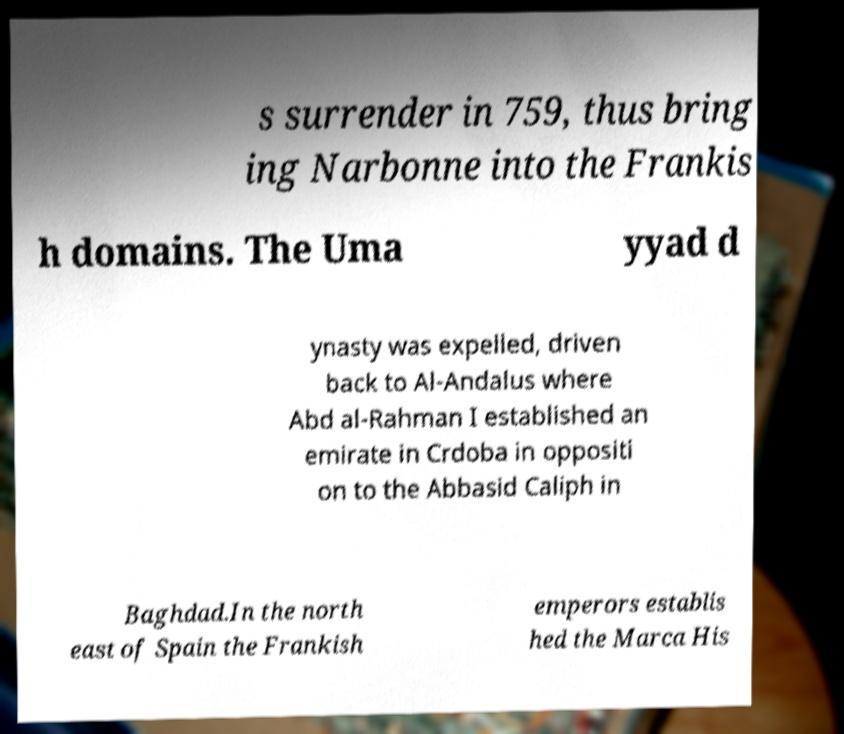I need the written content from this picture converted into text. Can you do that? s surrender in 759, thus bring ing Narbonne into the Frankis h domains. The Uma yyad d ynasty was expelled, driven back to Al-Andalus where Abd al-Rahman I established an emirate in Crdoba in oppositi on to the Abbasid Caliph in Baghdad.In the north east of Spain the Frankish emperors establis hed the Marca His 